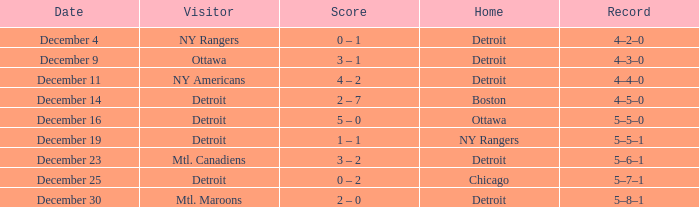What record has detroit as the home and mtl. maroons as the visitor? 5–8–1. 